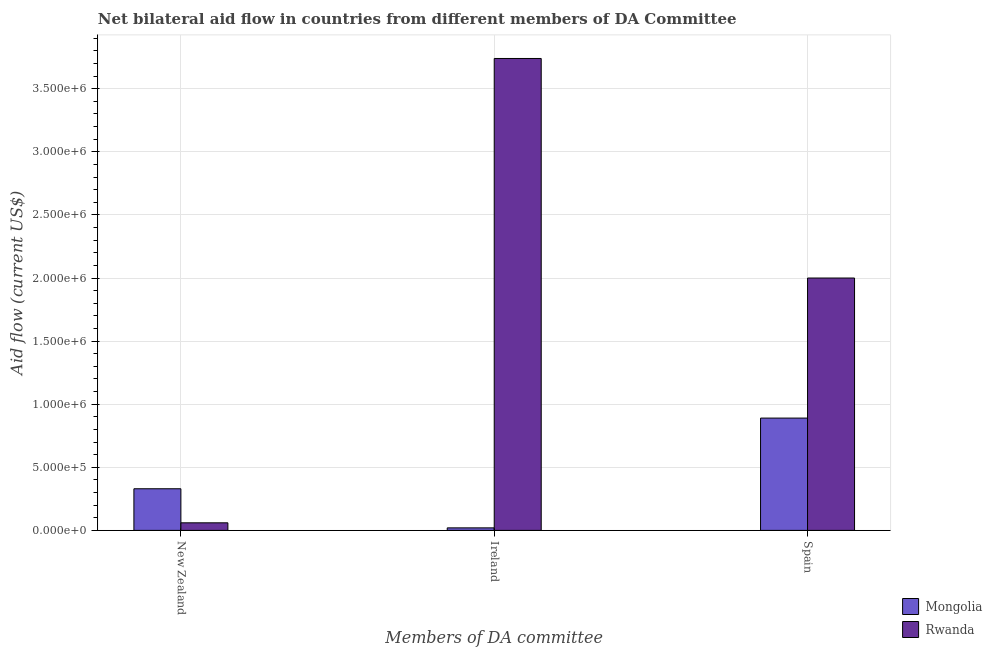Are the number of bars on each tick of the X-axis equal?
Provide a succinct answer. Yes. What is the amount of aid provided by ireland in Rwanda?
Make the answer very short. 3.74e+06. Across all countries, what is the maximum amount of aid provided by new zealand?
Provide a short and direct response. 3.30e+05. Across all countries, what is the minimum amount of aid provided by new zealand?
Provide a succinct answer. 6.00e+04. In which country was the amount of aid provided by new zealand maximum?
Provide a short and direct response. Mongolia. In which country was the amount of aid provided by ireland minimum?
Your response must be concise. Mongolia. What is the total amount of aid provided by ireland in the graph?
Make the answer very short. 3.76e+06. What is the difference between the amount of aid provided by ireland in Rwanda and that in Mongolia?
Provide a succinct answer. 3.72e+06. What is the difference between the amount of aid provided by ireland in Mongolia and the amount of aid provided by new zealand in Rwanda?
Ensure brevity in your answer.  -4.00e+04. What is the average amount of aid provided by spain per country?
Provide a short and direct response. 1.44e+06. What is the difference between the amount of aid provided by ireland and amount of aid provided by new zealand in Rwanda?
Offer a terse response. 3.68e+06. In how many countries, is the amount of aid provided by spain greater than 1700000 US$?
Your response must be concise. 1. Is the amount of aid provided by new zealand in Mongolia less than that in Rwanda?
Provide a succinct answer. No. What is the difference between the highest and the second highest amount of aid provided by spain?
Your response must be concise. 1.11e+06. What is the difference between the highest and the lowest amount of aid provided by ireland?
Offer a terse response. 3.72e+06. What does the 2nd bar from the left in Ireland represents?
Keep it short and to the point. Rwanda. What does the 1st bar from the right in Ireland represents?
Make the answer very short. Rwanda. Are all the bars in the graph horizontal?
Make the answer very short. No. Does the graph contain grids?
Offer a terse response. Yes. Where does the legend appear in the graph?
Keep it short and to the point. Bottom right. How are the legend labels stacked?
Keep it short and to the point. Vertical. What is the title of the graph?
Provide a short and direct response. Net bilateral aid flow in countries from different members of DA Committee. What is the label or title of the X-axis?
Your answer should be very brief. Members of DA committee. What is the Aid flow (current US$) of Rwanda in Ireland?
Offer a very short reply. 3.74e+06. What is the Aid flow (current US$) of Mongolia in Spain?
Your answer should be very brief. 8.90e+05. Across all Members of DA committee, what is the maximum Aid flow (current US$) in Mongolia?
Make the answer very short. 8.90e+05. Across all Members of DA committee, what is the maximum Aid flow (current US$) in Rwanda?
Offer a terse response. 3.74e+06. Across all Members of DA committee, what is the minimum Aid flow (current US$) of Rwanda?
Your answer should be very brief. 6.00e+04. What is the total Aid flow (current US$) of Mongolia in the graph?
Provide a succinct answer. 1.24e+06. What is the total Aid flow (current US$) of Rwanda in the graph?
Your response must be concise. 5.80e+06. What is the difference between the Aid flow (current US$) of Mongolia in New Zealand and that in Ireland?
Keep it short and to the point. 3.10e+05. What is the difference between the Aid flow (current US$) of Rwanda in New Zealand and that in Ireland?
Your response must be concise. -3.68e+06. What is the difference between the Aid flow (current US$) in Mongolia in New Zealand and that in Spain?
Offer a very short reply. -5.60e+05. What is the difference between the Aid flow (current US$) of Rwanda in New Zealand and that in Spain?
Offer a very short reply. -1.94e+06. What is the difference between the Aid flow (current US$) in Mongolia in Ireland and that in Spain?
Your answer should be compact. -8.70e+05. What is the difference between the Aid flow (current US$) in Rwanda in Ireland and that in Spain?
Offer a terse response. 1.74e+06. What is the difference between the Aid flow (current US$) in Mongolia in New Zealand and the Aid flow (current US$) in Rwanda in Ireland?
Your response must be concise. -3.41e+06. What is the difference between the Aid flow (current US$) of Mongolia in New Zealand and the Aid flow (current US$) of Rwanda in Spain?
Your answer should be very brief. -1.67e+06. What is the difference between the Aid flow (current US$) of Mongolia in Ireland and the Aid flow (current US$) of Rwanda in Spain?
Provide a succinct answer. -1.98e+06. What is the average Aid flow (current US$) in Mongolia per Members of DA committee?
Your answer should be compact. 4.13e+05. What is the average Aid flow (current US$) of Rwanda per Members of DA committee?
Offer a very short reply. 1.93e+06. What is the difference between the Aid flow (current US$) of Mongolia and Aid flow (current US$) of Rwanda in Ireland?
Your response must be concise. -3.72e+06. What is the difference between the Aid flow (current US$) of Mongolia and Aid flow (current US$) of Rwanda in Spain?
Your answer should be compact. -1.11e+06. What is the ratio of the Aid flow (current US$) of Mongolia in New Zealand to that in Ireland?
Offer a very short reply. 16.5. What is the ratio of the Aid flow (current US$) in Rwanda in New Zealand to that in Ireland?
Your answer should be compact. 0.02. What is the ratio of the Aid flow (current US$) in Mongolia in New Zealand to that in Spain?
Give a very brief answer. 0.37. What is the ratio of the Aid flow (current US$) in Mongolia in Ireland to that in Spain?
Your answer should be very brief. 0.02. What is the ratio of the Aid flow (current US$) in Rwanda in Ireland to that in Spain?
Offer a very short reply. 1.87. What is the difference between the highest and the second highest Aid flow (current US$) in Mongolia?
Offer a very short reply. 5.60e+05. What is the difference between the highest and the second highest Aid flow (current US$) in Rwanda?
Provide a short and direct response. 1.74e+06. What is the difference between the highest and the lowest Aid flow (current US$) in Mongolia?
Keep it short and to the point. 8.70e+05. What is the difference between the highest and the lowest Aid flow (current US$) of Rwanda?
Provide a short and direct response. 3.68e+06. 